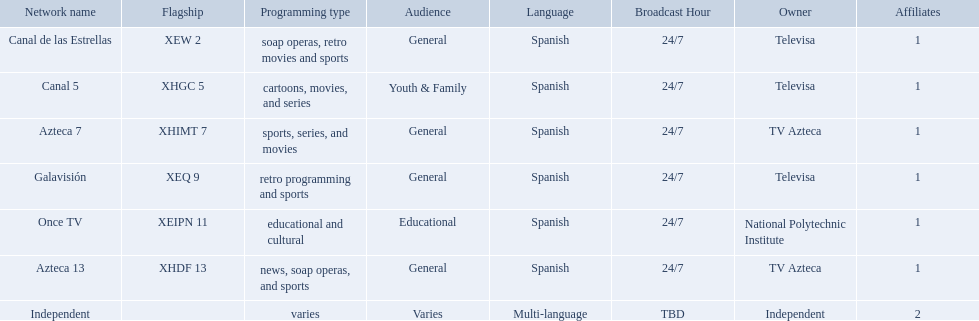What are each of the networks? Canal de las Estrellas, Canal 5, Azteca 7, Galavisión, Once TV, Azteca 13, Independent. Who owns them? Televisa, Televisa, TV Azteca, Televisa, National Polytechnic Institute, TV Azteca, Independent. Which networks aren't owned by televisa? Azteca 7, Once TV, Azteca 13, Independent. What type of programming do those networks offer? Sports, series, and movies, educational and cultural, news, soap operas, and sports, varies. And which network is the only one with sports? Azteca 7. What station shows cartoons? Canal 5. What station shows soap operas? Canal de las Estrellas. Would you mind parsing the complete table? {'header': ['Network name', 'Flagship', 'Programming type', 'Audience', 'Language', 'Broadcast Hour', 'Owner', 'Affiliates'], 'rows': [['Canal de las Estrellas', 'XEW 2', 'soap operas, retro movies and sports', 'General', 'Spanish', '24/7', 'Televisa', '1'], ['Canal 5', 'XHGC 5', 'cartoons, movies, and series', 'Youth & Family', 'Spanish', '24/7', 'Televisa', '1'], ['Azteca 7', 'XHIMT 7', 'sports, series, and movies', 'General', 'Spanish', '24/7', 'TV Azteca', '1'], ['Galavisión', 'XEQ 9', 'retro programming and sports', 'General', 'Spanish', '24/7', 'Televisa', '1'], ['Once TV', 'XEIPN 11', 'educational and cultural', 'Educational', 'Spanish', '24/7', 'National Polytechnic Institute', '1'], ['Azteca 13', 'XHDF 13', 'news, soap operas, and sports', 'General', 'Spanish', '24/7', 'TV Azteca', '1'], ['Independent', '', 'varies', 'Varies', 'Multi-language', 'TBD', 'Independent', '2']]} What station shows sports? Azteca 7. What stations show sports? Soap operas, retro movies and sports, retro programming and sports, news, soap operas, and sports. What of these is not affiliated with televisa? Azteca 7. 